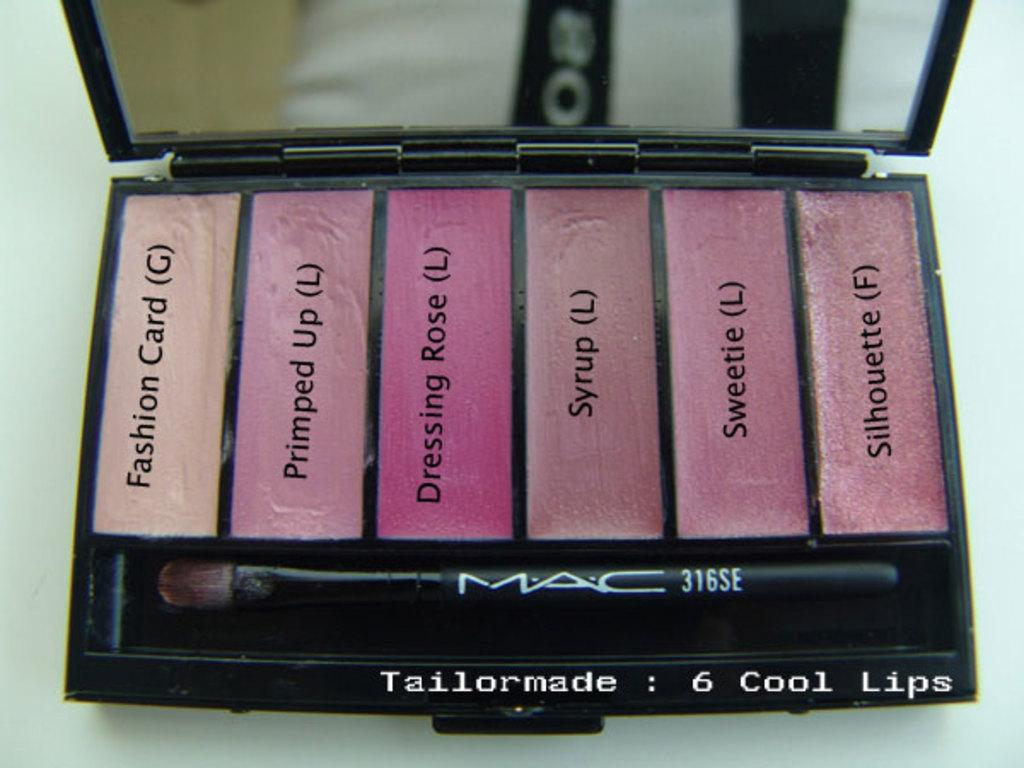<image>
Share a concise interpretation of the image provided. A makeup kit with the text 6 cool lips printed at the bottom. 